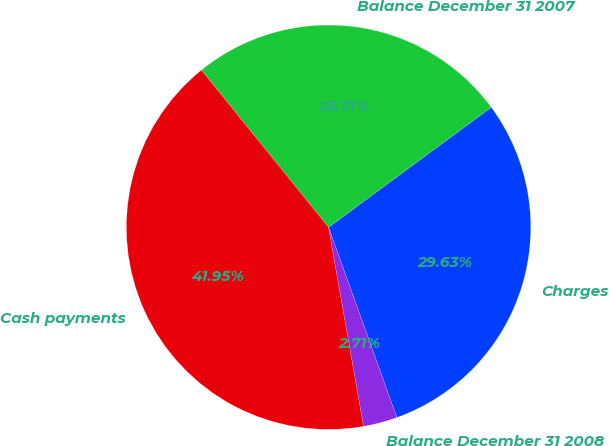Convert chart. <chart><loc_0><loc_0><loc_500><loc_500><pie_chart><fcel>Charges<fcel>Balance December 31 2007<fcel>Cash payments<fcel>Balance December 31 2008<nl><fcel>29.63%<fcel>25.71%<fcel>41.95%<fcel>2.71%<nl></chart> 